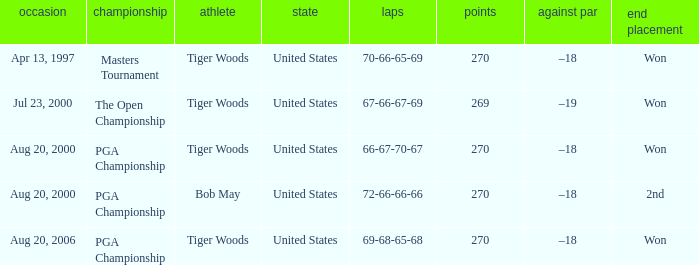What is the worst (highest) score? 270.0. Help me parse the entirety of this table. {'header': ['occasion', 'championship', 'athlete', 'state', 'laps', 'points', 'against par', 'end placement'], 'rows': [['Apr 13, 1997', 'Masters Tournament', 'Tiger Woods', 'United States', '70-66-65-69', '270', '–18', 'Won'], ['Jul 23, 2000', 'The Open Championship', 'Tiger Woods', 'United States', '67-66-67-69', '269', '–19', 'Won'], ['Aug 20, 2000', 'PGA Championship', 'Tiger Woods', 'United States', '66-67-70-67', '270', '–18', 'Won'], ['Aug 20, 2000', 'PGA Championship', 'Bob May', 'United States', '72-66-66-66', '270', '–18', '2nd'], ['Aug 20, 2006', 'PGA Championship', 'Tiger Woods', 'United States', '69-68-65-68', '270', '–18', 'Won']]} 